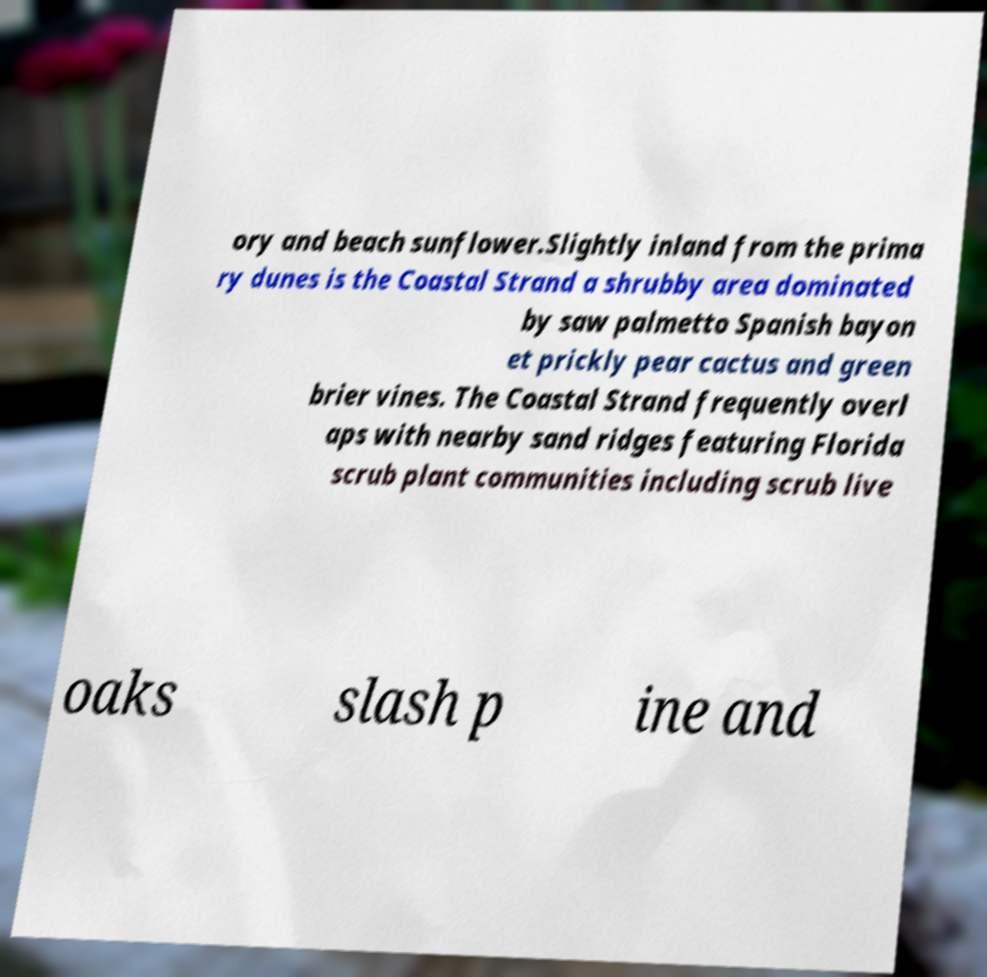There's text embedded in this image that I need extracted. Can you transcribe it verbatim? ory and beach sunflower.Slightly inland from the prima ry dunes is the Coastal Strand a shrubby area dominated by saw palmetto Spanish bayon et prickly pear cactus and green brier vines. The Coastal Strand frequently overl aps with nearby sand ridges featuring Florida scrub plant communities including scrub live oaks slash p ine and 